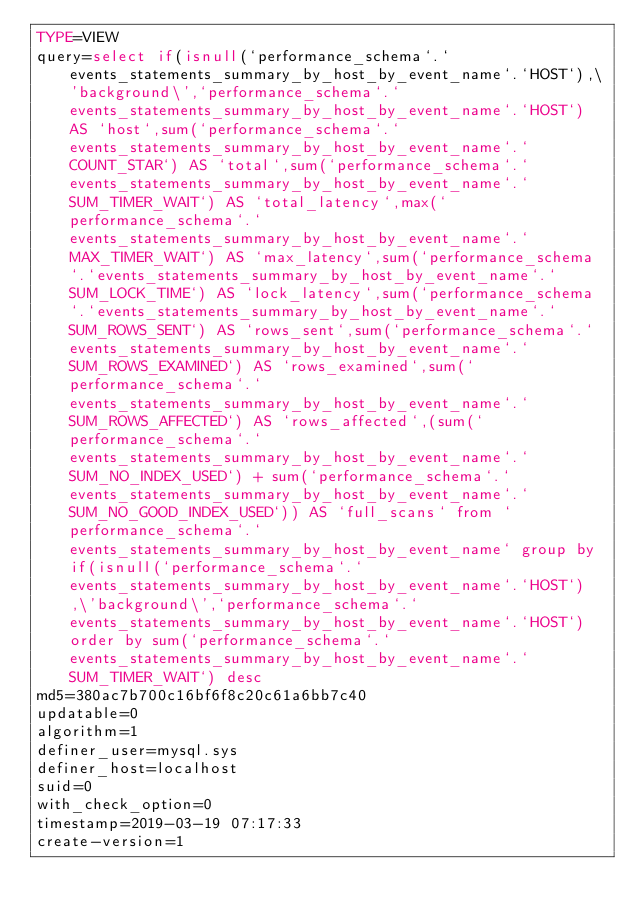Convert code to text. <code><loc_0><loc_0><loc_500><loc_500><_VisualBasic_>TYPE=VIEW
query=select if(isnull(`performance_schema`.`events_statements_summary_by_host_by_event_name`.`HOST`),\'background\',`performance_schema`.`events_statements_summary_by_host_by_event_name`.`HOST`) AS `host`,sum(`performance_schema`.`events_statements_summary_by_host_by_event_name`.`COUNT_STAR`) AS `total`,sum(`performance_schema`.`events_statements_summary_by_host_by_event_name`.`SUM_TIMER_WAIT`) AS `total_latency`,max(`performance_schema`.`events_statements_summary_by_host_by_event_name`.`MAX_TIMER_WAIT`) AS `max_latency`,sum(`performance_schema`.`events_statements_summary_by_host_by_event_name`.`SUM_LOCK_TIME`) AS `lock_latency`,sum(`performance_schema`.`events_statements_summary_by_host_by_event_name`.`SUM_ROWS_SENT`) AS `rows_sent`,sum(`performance_schema`.`events_statements_summary_by_host_by_event_name`.`SUM_ROWS_EXAMINED`) AS `rows_examined`,sum(`performance_schema`.`events_statements_summary_by_host_by_event_name`.`SUM_ROWS_AFFECTED`) AS `rows_affected`,(sum(`performance_schema`.`events_statements_summary_by_host_by_event_name`.`SUM_NO_INDEX_USED`) + sum(`performance_schema`.`events_statements_summary_by_host_by_event_name`.`SUM_NO_GOOD_INDEX_USED`)) AS `full_scans` from `performance_schema`.`events_statements_summary_by_host_by_event_name` group by if(isnull(`performance_schema`.`events_statements_summary_by_host_by_event_name`.`HOST`),\'background\',`performance_schema`.`events_statements_summary_by_host_by_event_name`.`HOST`) order by sum(`performance_schema`.`events_statements_summary_by_host_by_event_name`.`SUM_TIMER_WAIT`) desc
md5=380ac7b700c16bf6f8c20c61a6bb7c40
updatable=0
algorithm=1
definer_user=mysql.sys
definer_host=localhost
suid=0
with_check_option=0
timestamp=2019-03-19 07:17:33
create-version=1</code> 